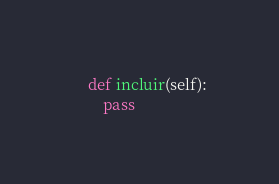<code> <loc_0><loc_0><loc_500><loc_500><_Python_>
    def incluir(self):
        pass

</code> 